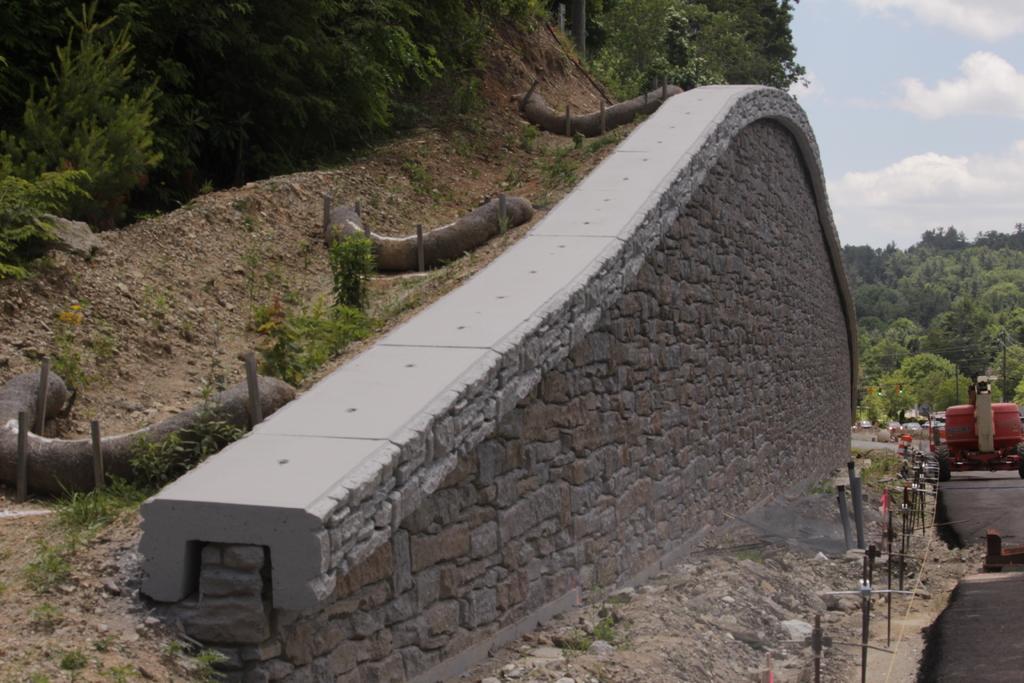Could you give a brief overview of what you see in this image? In the picture we can see a hill to it, we can see a wall which is in kind of supporting the hill and beside it, we can see some mud path and near it, we can see a rail and road and any vehicle on it and in the background we can see trees, plants and sky with clouds. 